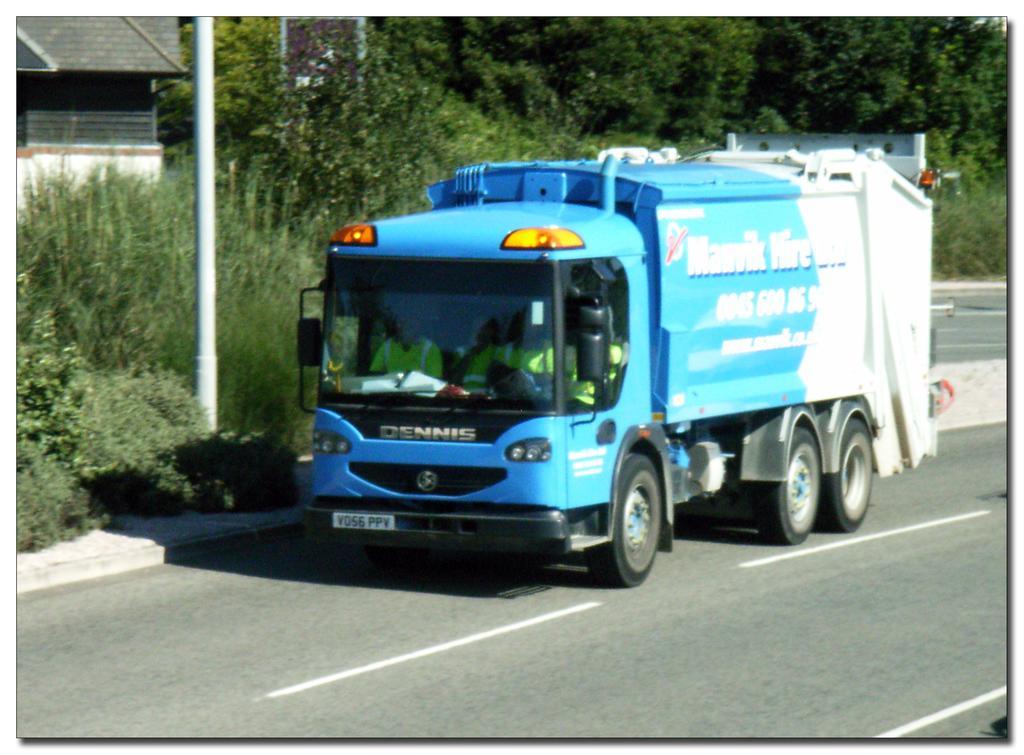In one or two sentences, can you explain what this image depicts? In the center of the image we can see a vehicle on the road. On the left there is a shed. In the background there are trees and we can see a pole. 